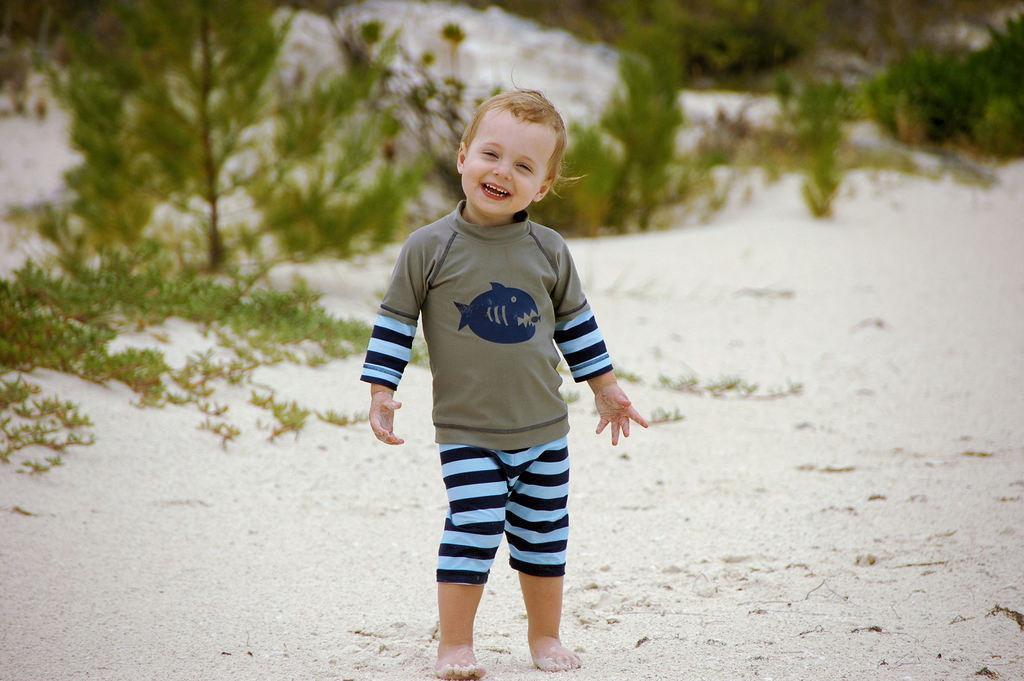Who is the main subject in the image? There is a boy in the image. What is the boy doing in the image? The boy is standing and smiling. What can be seen in the background of the image? There are planets and grass visible in the background of the image. How is the background of the image depicted? The background of the image is blurred. What type of cup is the boy holding in the image? There is no cup present in the image; the boy is not holding anything. 